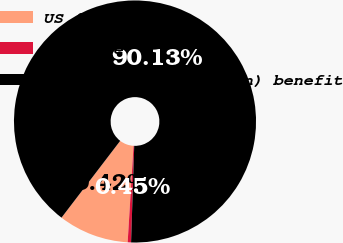Convert chart. <chart><loc_0><loc_0><loc_500><loc_500><pie_chart><fcel>US federal<fcel>US state<fcel>Income tax (provision) benefit<nl><fcel>9.42%<fcel>0.45%<fcel>90.14%<nl></chart> 